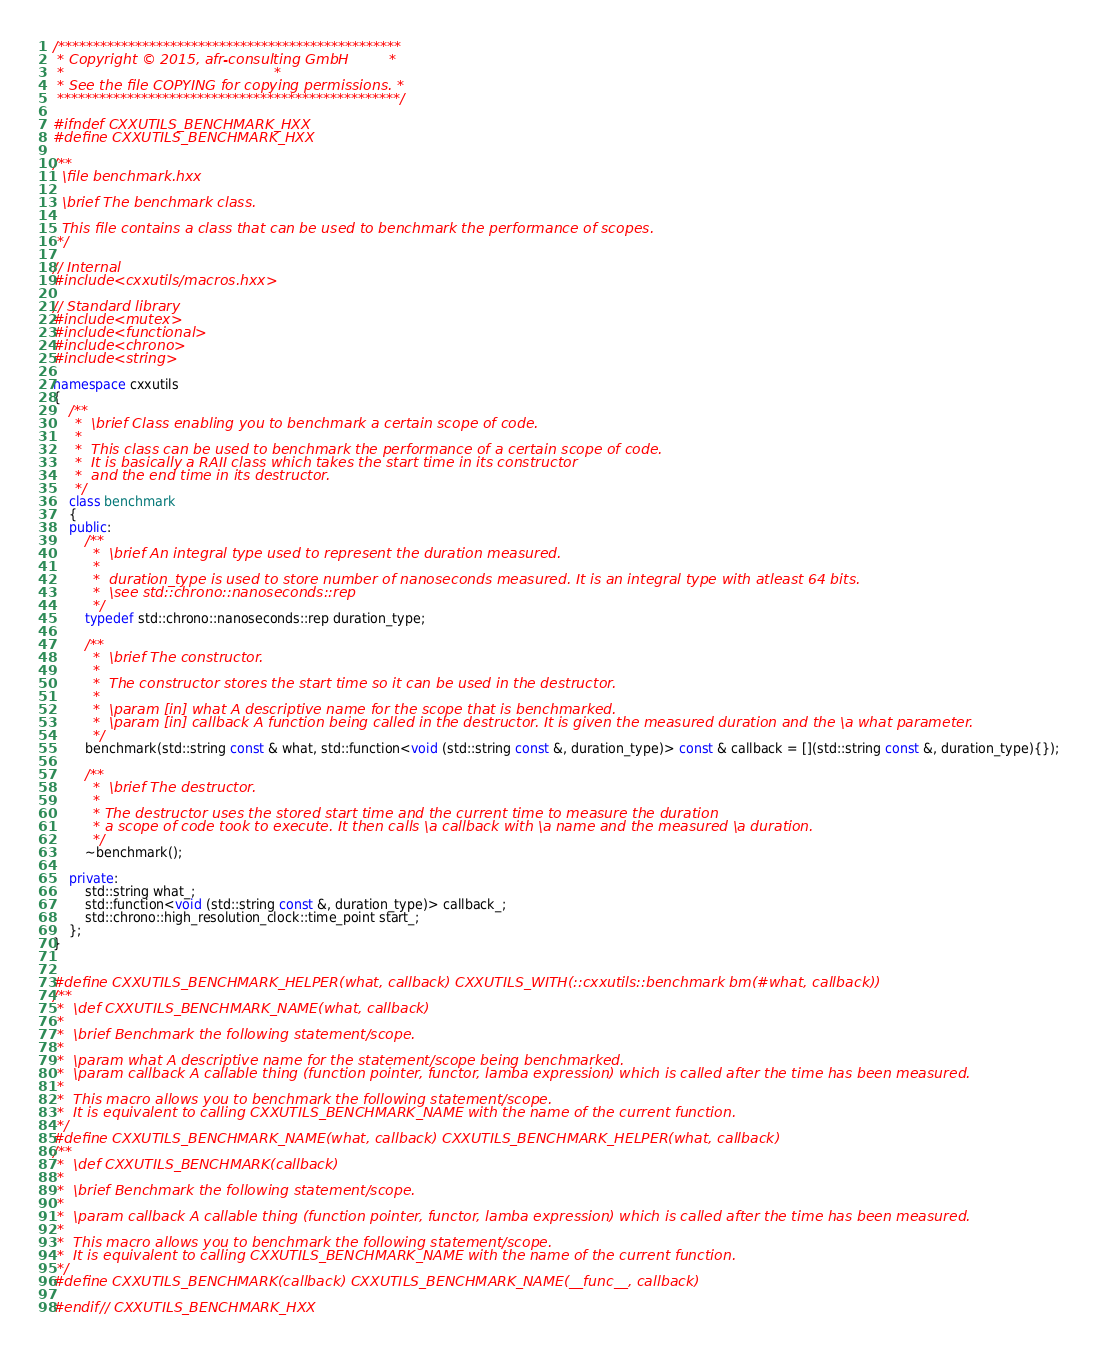Convert code to text. <code><loc_0><loc_0><loc_500><loc_500><_C++_>/*************************************************
 * Copyright © 2015, afr-consulting GmbH         *
 *                                               *
 * See the file COPYING for copying permissions. *
 *************************************************/

#ifndef CXXUTILS_BENCHMARK_HXX
#define CXXUTILS_BENCHMARK_HXX

/**
  \file benchmark.hxx

  \brief The benchmark class.

  This file contains a class that can be used to benchmark the performance of scopes.
 */

// Internal
#include <cxxutils/macros.hxx>

// Standard library
#include <mutex>
#include <functional>
#include <chrono>
#include <string>

namespace cxxutils
{
    /**
     *  \brief Class enabling you to benchmark a certain scope of code.
     *
     *  This class can be used to benchmark the performance of a certain scope of code.
     *  It is basically a RAII class which takes the start time in its constructor
     *  and the end time in its destructor.
     */
    class benchmark
    {
    public:
        /**
         *  \brief An integral type used to represent the duration measured.
         *
         *  duration_type is used to store number of nanoseconds measured. It is an integral type with atleast 64 bits.
         *  \see std::chrono::nanoseconds::rep
         */
        typedef std::chrono::nanoseconds::rep duration_type;

        /**
         *  \brief The constructor.
         *
         *  The constructor stores the start time so it can be used in the destructor.
         *
         *  \param [in] what A descriptive name for the scope that is benchmarked.
         *  \param [in] callback A function being called in the destructor. It is given the measured duration and the \a what parameter.
         */
        benchmark(std::string const & what, std::function<void (std::string const &, duration_type)> const & callback = [](std::string const &, duration_type){});

        /**
         *  \brief The destructor.
         *
         * The destructor uses the stored start time and the current time to measure the duration
         * a scope of code took to execute. It then calls \a callback with \a name and the measured \a duration.
         */
        ~benchmark();

    private:
        std::string what_;
        std::function<void (std::string const &, duration_type)> callback_;
        std::chrono::high_resolution_clock::time_point start_;
    };
}


#define CXXUTILS_BENCHMARK_HELPER(what, callback) CXXUTILS_WITH(::cxxutils::benchmark bm(#what, callback))
/**
 *  \def CXXUTILS_BENCHMARK_NAME(what, callback)
 *
 *  \brief Benchmark the following statement/scope.
 *
 *  \param what A descriptive name for the statement/scope being benchmarked.
 *  \param callback A callable thing (function pointer, functor, lamba expression) which is called after the time has been measured.
 *
 *  This macro allows you to benchmark the following statement/scope.
 *  It is equivalent to calling CXXUTILS_BENCHMARK_NAME with the name of the current function.
 */
#define CXXUTILS_BENCHMARK_NAME(what, callback) CXXUTILS_BENCHMARK_HELPER(what, callback)
/**
 *  \def CXXUTILS_BENCHMARK(callback)
 *
 *  \brief Benchmark the following statement/scope.
 *
 *  \param callback A callable thing (function pointer, functor, lamba expression) which is called after the time has been measured.
 *
 *  This macro allows you to benchmark the following statement/scope.
 *  It is equivalent to calling CXXUTILS_BENCHMARK_NAME with the name of the current function.
 */
#define CXXUTILS_BENCHMARK(callback) CXXUTILS_BENCHMARK_NAME(__func__, callback)

#endif // CXXUTILS_BENCHMARK_HXX
</code> 